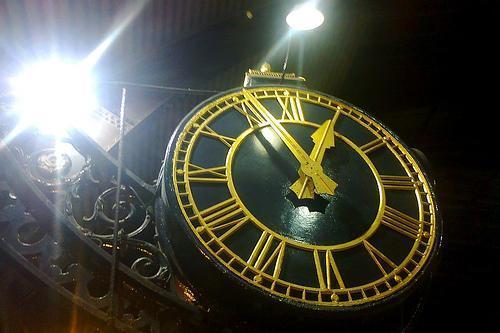How many clocks are in the picture?
Give a very brief answer. 1. 